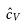Convert formula to latex. <formula><loc_0><loc_0><loc_500><loc_500>\hat { c } _ { V }</formula> 